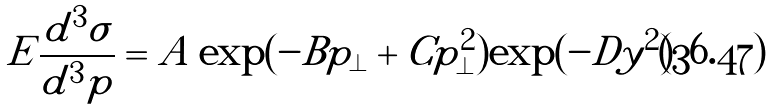Convert formula to latex. <formula><loc_0><loc_0><loc_500><loc_500>E \frac { d ^ { 3 } { \sigma } } { d ^ { 3 } p } = A \exp ( - B p _ { \perp } + C p _ { \perp } ^ { 2 } ) \exp ( - D y ^ { 2 } )</formula> 